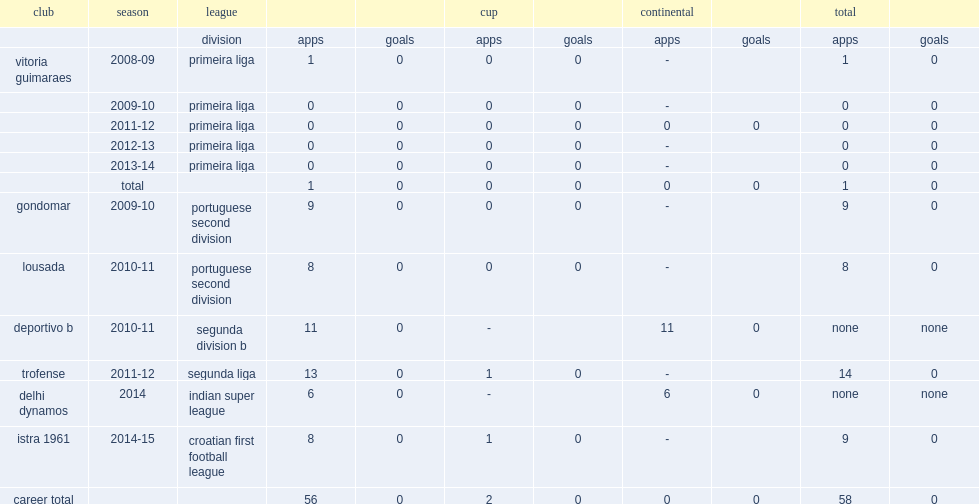In 2014, which league did dinis join delhi dynamos fc? Indian super league. 